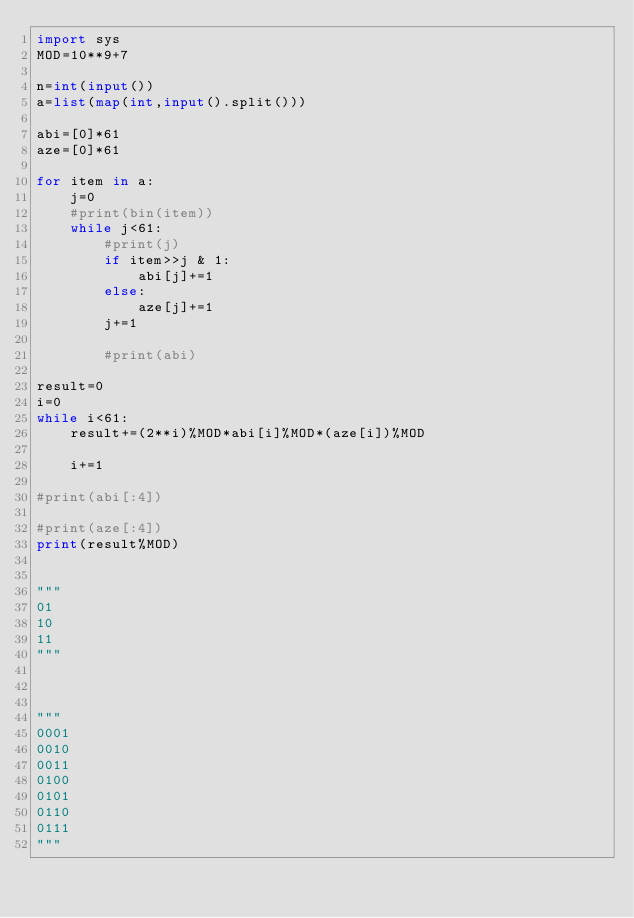Convert code to text. <code><loc_0><loc_0><loc_500><loc_500><_Python_>import sys
MOD=10**9+7

n=int(input())
a=list(map(int,input().split()))

abi=[0]*61
aze=[0]*61

for item in a:
    j=0
    #print(bin(item))
    while j<61:
        #print(j)
        if item>>j & 1:
            abi[j]+=1
        else:
            aze[j]+=1
        j+=1

        #print(abi)

result=0
i=0
while i<61:
    result+=(2**i)%MOD*abi[i]%MOD*(aze[i])%MOD

    i+=1

#print(abi[:4])

#print(aze[:4])
print(result%MOD)


"""
01
10
11
"""



"""
0001
0010
0011
0100
0101
0110
0111
"""</code> 